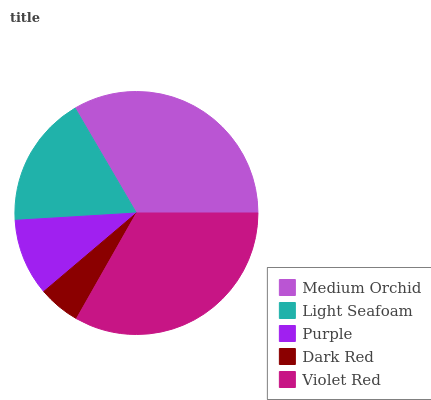Is Dark Red the minimum?
Answer yes or no. Yes. Is Medium Orchid the maximum?
Answer yes or no. Yes. Is Light Seafoam the minimum?
Answer yes or no. No. Is Light Seafoam the maximum?
Answer yes or no. No. Is Medium Orchid greater than Light Seafoam?
Answer yes or no. Yes. Is Light Seafoam less than Medium Orchid?
Answer yes or no. Yes. Is Light Seafoam greater than Medium Orchid?
Answer yes or no. No. Is Medium Orchid less than Light Seafoam?
Answer yes or no. No. Is Light Seafoam the high median?
Answer yes or no. Yes. Is Light Seafoam the low median?
Answer yes or no. Yes. Is Dark Red the high median?
Answer yes or no. No. Is Violet Red the low median?
Answer yes or no. No. 